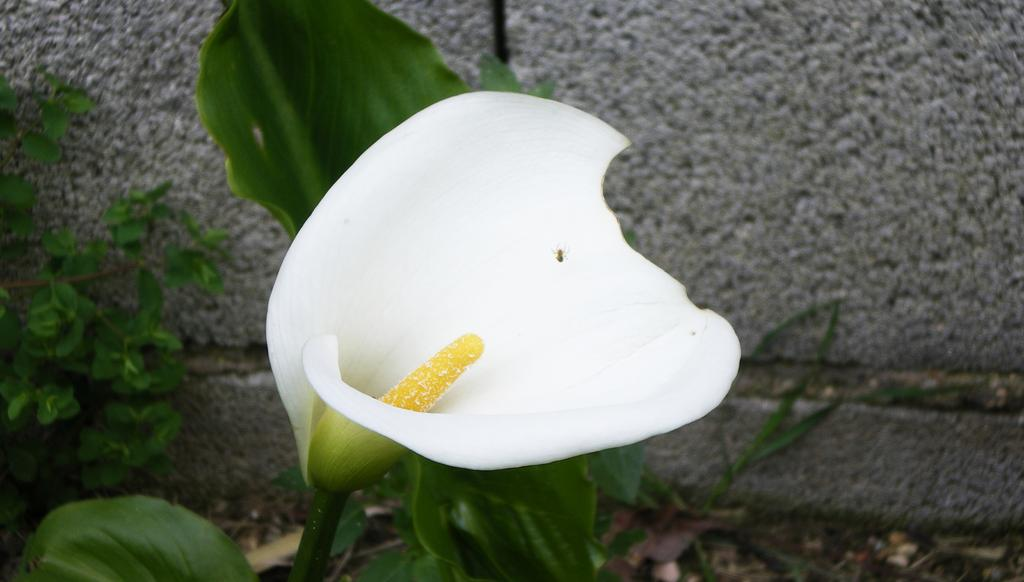What is on the flower in the image? There is an insect on a flower in the image. What else can be seen in the image besides the insect and flower? There are plants visible in the image. What type of structure is present in the image? There is a wall in the image. What type of comb is the baby using in the image? There is no baby or comb present in the image; it features an insect on a flower and plants. 